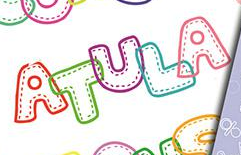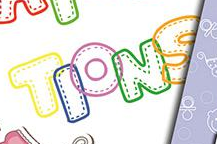Identify the words shown in these images in order, separated by a semicolon. ATULA; TIONS 